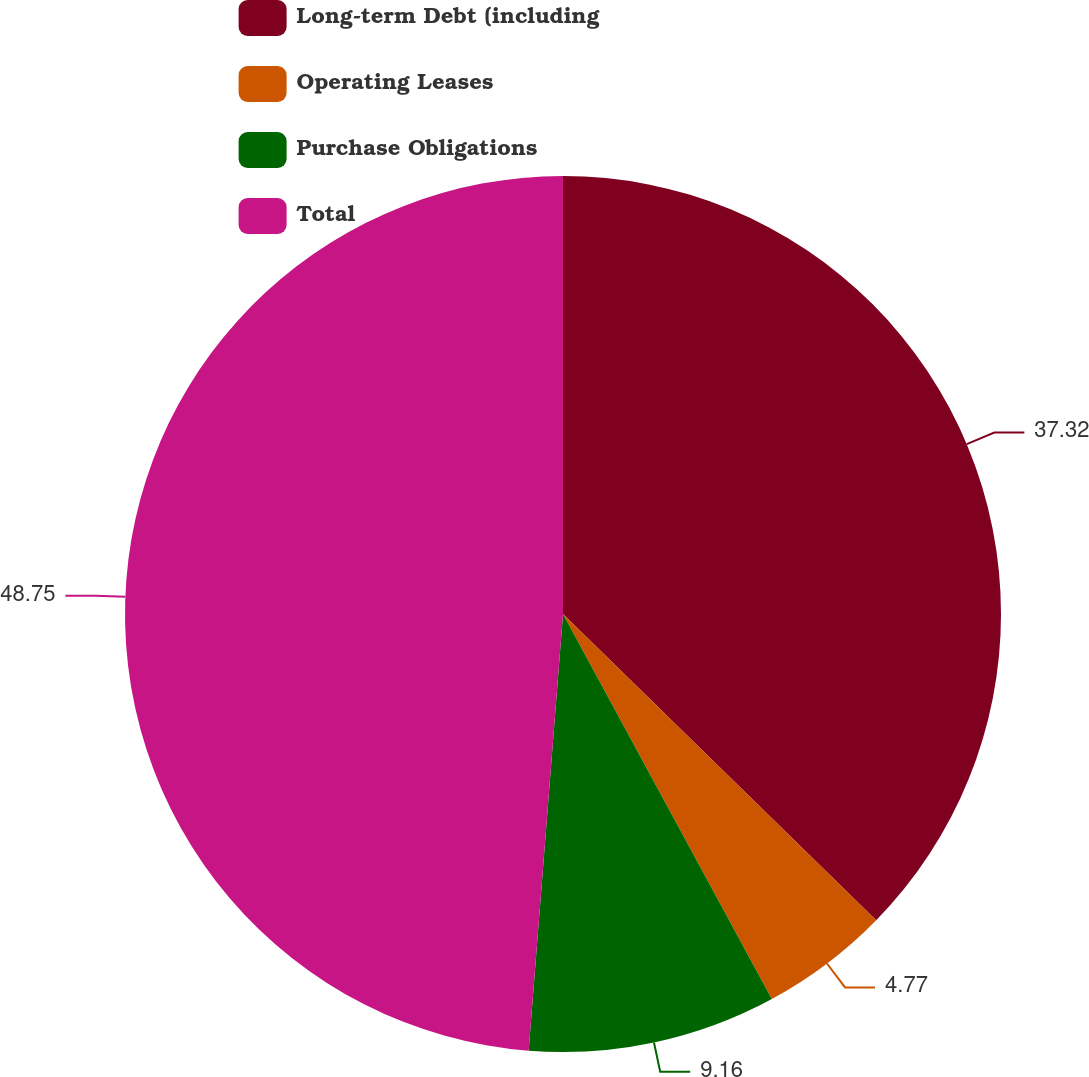Convert chart. <chart><loc_0><loc_0><loc_500><loc_500><pie_chart><fcel>Long-term Debt (including<fcel>Operating Leases<fcel>Purchase Obligations<fcel>Total<nl><fcel>37.32%<fcel>4.77%<fcel>9.16%<fcel>48.75%<nl></chart> 